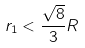Convert formula to latex. <formula><loc_0><loc_0><loc_500><loc_500>r _ { 1 } < \frac { \sqrt { 8 } } { 3 } R</formula> 